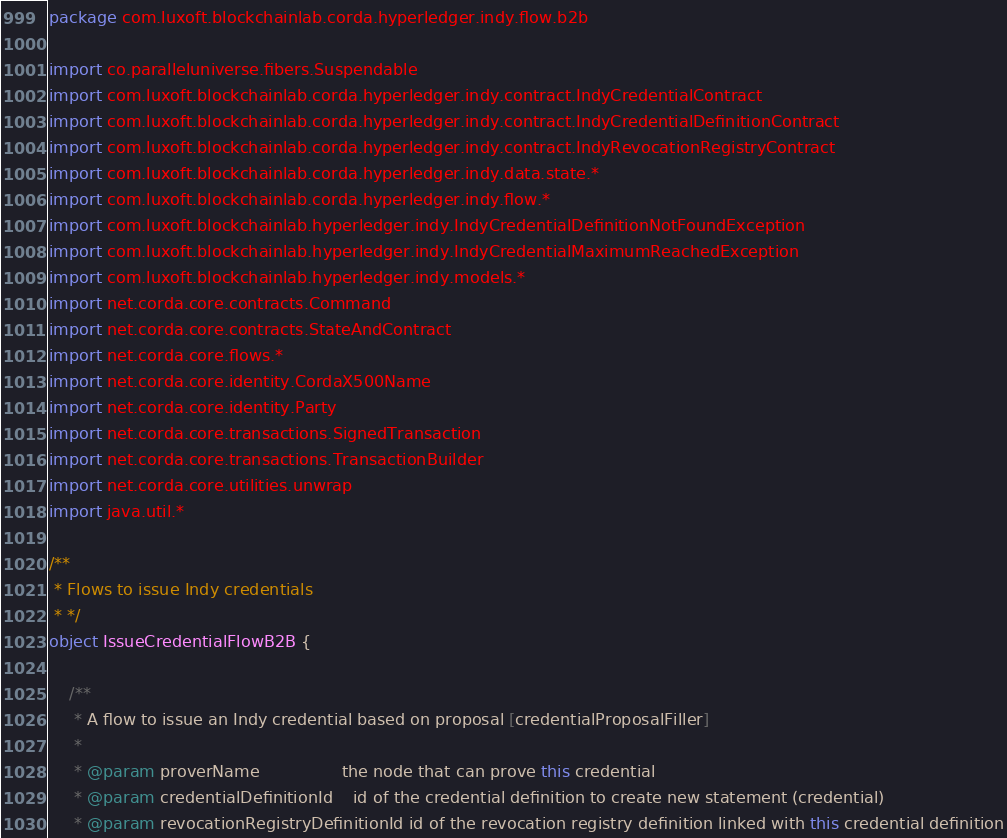Convert code to text. <code><loc_0><loc_0><loc_500><loc_500><_Kotlin_>package com.luxoft.blockchainlab.corda.hyperledger.indy.flow.b2b

import co.paralleluniverse.fibers.Suspendable
import com.luxoft.blockchainlab.corda.hyperledger.indy.contract.IndyCredentialContract
import com.luxoft.blockchainlab.corda.hyperledger.indy.contract.IndyCredentialDefinitionContract
import com.luxoft.blockchainlab.corda.hyperledger.indy.contract.IndyRevocationRegistryContract
import com.luxoft.blockchainlab.corda.hyperledger.indy.data.state.*
import com.luxoft.blockchainlab.corda.hyperledger.indy.flow.*
import com.luxoft.blockchainlab.hyperledger.indy.IndyCredentialDefinitionNotFoundException
import com.luxoft.blockchainlab.hyperledger.indy.IndyCredentialMaximumReachedException
import com.luxoft.blockchainlab.hyperledger.indy.models.*
import net.corda.core.contracts.Command
import net.corda.core.contracts.StateAndContract
import net.corda.core.flows.*
import net.corda.core.identity.CordaX500Name
import net.corda.core.identity.Party
import net.corda.core.transactions.SignedTransaction
import net.corda.core.transactions.TransactionBuilder
import net.corda.core.utilities.unwrap
import java.util.*

/**
 * Flows to issue Indy credentials
 * */
object IssueCredentialFlowB2B {

    /**
     * A flow to issue an Indy credential based on proposal [credentialProposalFiller]
     *
     * @param proverName                the node that can prove this credential
     * @param credentialDefinitionId    id of the credential definition to create new statement (credential)
     * @param revocationRegistryDefinitionId id of the revocation registry definition linked with this credential definition</code> 